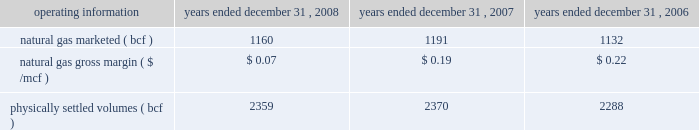2022 lower 2008 storage margins related to storage risk management positions and the impact of changes in natural gas prices on these positions ; and 2022 fewer opportunities to optimize storage capacity due to the significant decline in natural gas prices in the second half of 2008 ; o a decrease of $ 9.7 million in physical storage margins due to a lower of cost or market write-down on natural gas inventory ; and o a decrease of $ 2.1 million due to colder than anticipated weather and market conditions that increased the supply cost of managing our peaking and load-following services and provided fewer opportunities to increase margins through optimization activities , primarily in the first quarter of 2008 ; partially offset by o an increase of $ 15.8 million from changes in the unrealized fair value of derivative instruments associated with storage and marketing activities and improved marketing margins , which benefited from price movements and optimization activities .
Operating costs decreased primarily due to lower employee-related costs and depreciation expense .
2007 vs .
2006 - net margin decreased primarily due to : 2022 a decrease of $ 22.0 million in transportation margins , net of hedging activities , associated with changes in the unrealized fair value of derivative instruments and the impact of a force majeure event on the cheyenne plains gas pipeline , as more fully described below ; 2022 a decrease of $ 5.0 million in retail activities from lower physical margins due to market conditions and increased competition ; 2022 a decrease of $ 4.3 million in financial trading margins that was partially offset by 2022 an increase of $ 4.9 million in storage and marketing margins , net of hedging activities , related to : o an increase in physical storage margins , net of hedging activity , due to higher realized seasonal storage spreads and optimization activities ; partially offset by o a decrease in marketing margins ; and o a net increase in the cost associated with managing our peaking and load following services , slightly offset by higher demand fees collected for these services .
In september 2007 , a portion of the volume contracted under our firm transportation agreement with cheyenne plains gas pipeline company was curtailed due to a fire at a cheyenne plains pipeline compressor station .
The fire damaged a significant amount of instrumentation and electrical wiring , causing cheyenne plains gas pipeline company to declare a force majeure event on the pipeline .
This firm commitment was hedged in accordance with statement 133 .
The discontinuance of fair value hedge accounting on the portion of the firm commitment that was impacted by the force majeure event resulted in a loss of approximately $ 5.5 million that was recognized in the third quarter of 2007 , of which $ 2.4 million of insurance proceeds were recovered and recognized in the first quarter of 2008 .
Cheyenne plains gas pipeline company resumed full operations in november 2007 .
Operating costs decreased primarily due to decreased legal and employee-related costs , and reduced ad-valorem tax expense .
Selected operating information - the table sets forth certain selected operating information for our energy services segment for the periods indicated. .
Our natural gas in storage at december 31 , 2008 , was 81.9 bcf , compared with 66.7 bcf at december 31 , 2007 .
At december 31 , 2008 , our total natural gas storage capacity under lease was 91 bcf , compared with 96 bcf at december 31 , natural gas volumes marketed decreased slightly during 2008 , compared with 2007 , due to increased injections in the third quarter of 2008 .
In addition , demand for natural gas was impacted by weather-related events in the third quarter of 2008 , including a 15 percent decrease in cooling degree-days and demand disruption caused by hurricane ike. .
What was the percentage change in natural gas gross margin ( $ /mcf ) between 2007 and 2008? 
Computations: ((0.07 - 0.19) / 0.19)
Answer: -0.63158. 